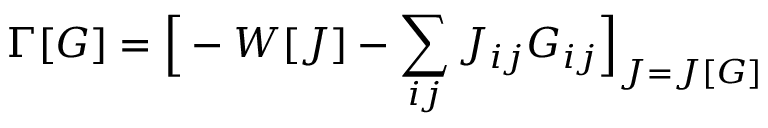<formula> <loc_0><loc_0><loc_500><loc_500>\Gamma [ G ] = { \left [ } - W [ J ] - \sum _ { i j } J _ { i j } G _ { i j } { \right ] } _ { J = J [ G ] }</formula> 